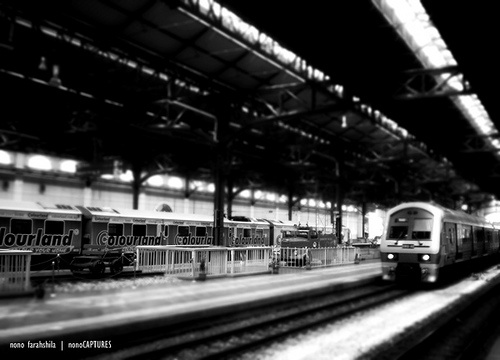Describe the objects in this image and their specific colors. I can see train in black, gray, lightgray, and darkgray tones, train in black, gray, lightgray, and darkgray tones, and truck in black, gray, darkgray, and lightgray tones in this image. 